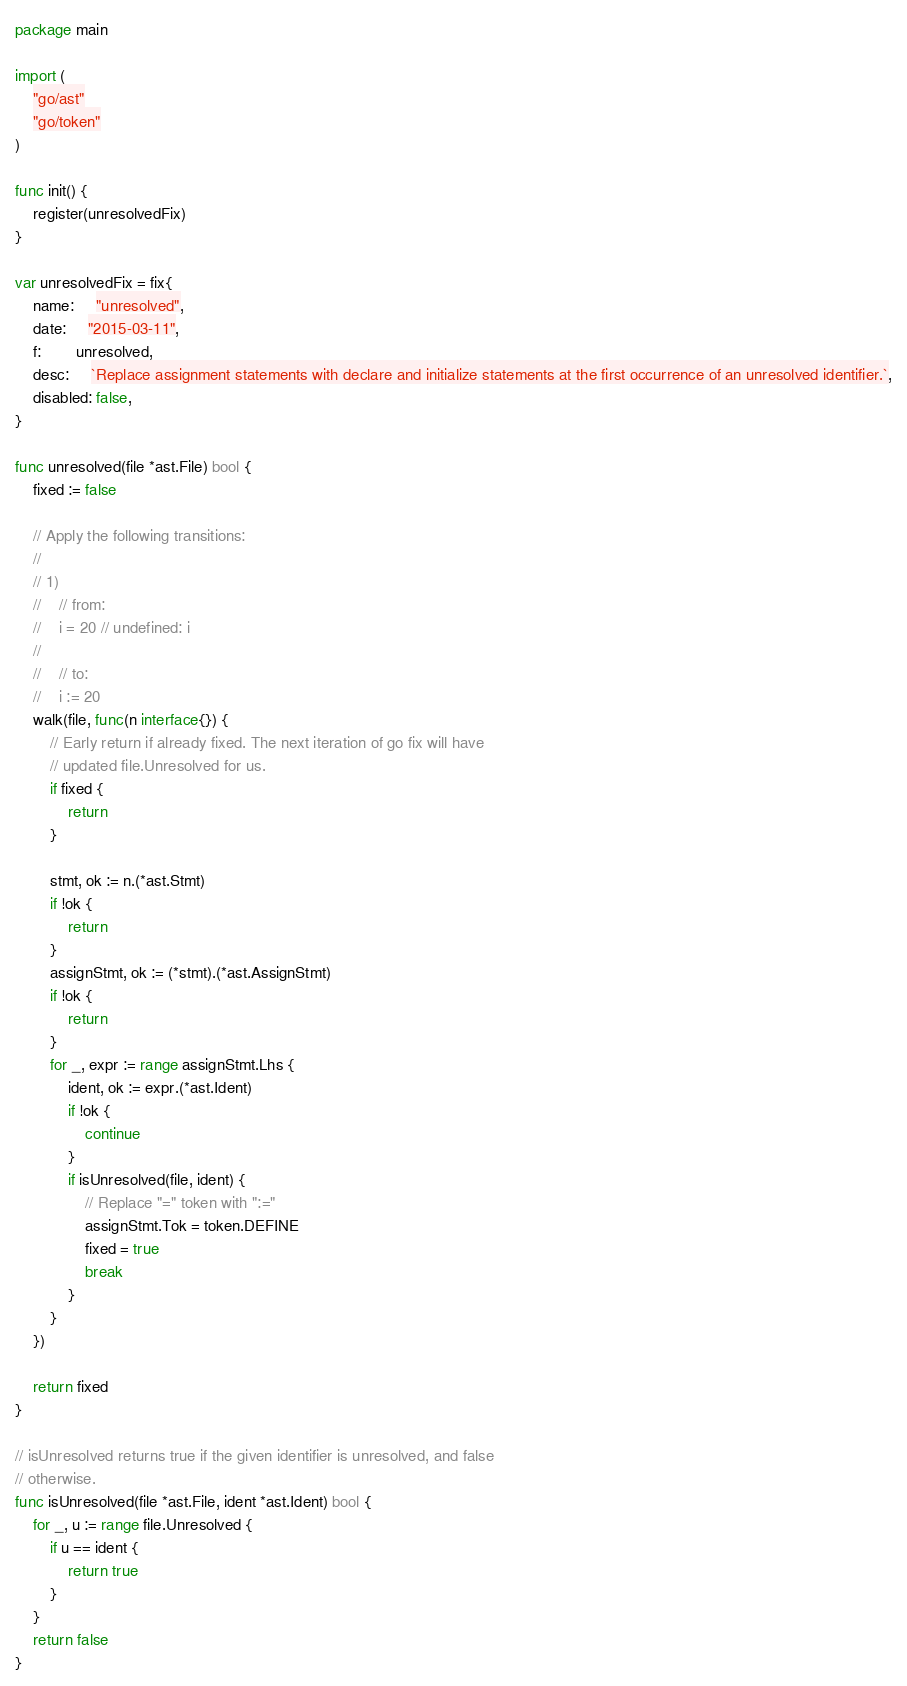<code> <loc_0><loc_0><loc_500><loc_500><_Go_>package main

import (
	"go/ast"
	"go/token"
)

func init() {
	register(unresolvedFix)
}

var unresolvedFix = fix{
	name:     "unresolved",
	date:     "2015-03-11",
	f:        unresolved,
	desc:     `Replace assignment statements with declare and initialize statements at the first occurrence of an unresolved identifier.`,
	disabled: false,
}

func unresolved(file *ast.File) bool {
	fixed := false

	// Apply the following transitions:
	//
	// 1)
	//    // from:
	//    i = 20 // undefined: i
	//
	//    // to:
	//    i := 20
	walk(file, func(n interface{}) {
		// Early return if already fixed. The next iteration of go fix will have
		// updated file.Unresolved for us.
		if fixed {
			return
		}

		stmt, ok := n.(*ast.Stmt)
		if !ok {
			return
		}
		assignStmt, ok := (*stmt).(*ast.AssignStmt)
		if !ok {
			return
		}
		for _, expr := range assignStmt.Lhs {
			ident, ok := expr.(*ast.Ident)
			if !ok {
				continue
			}
			if isUnresolved(file, ident) {
				// Replace "=" token with ":="
				assignStmt.Tok = token.DEFINE
				fixed = true
				break
			}
		}
	})

	return fixed
}

// isUnresolved returns true if the given identifier is unresolved, and false
// otherwise.
func isUnresolved(file *ast.File, ident *ast.Ident) bool {
	for _, u := range file.Unresolved {
		if u == ident {
			return true
		}
	}
	return false
}
</code> 